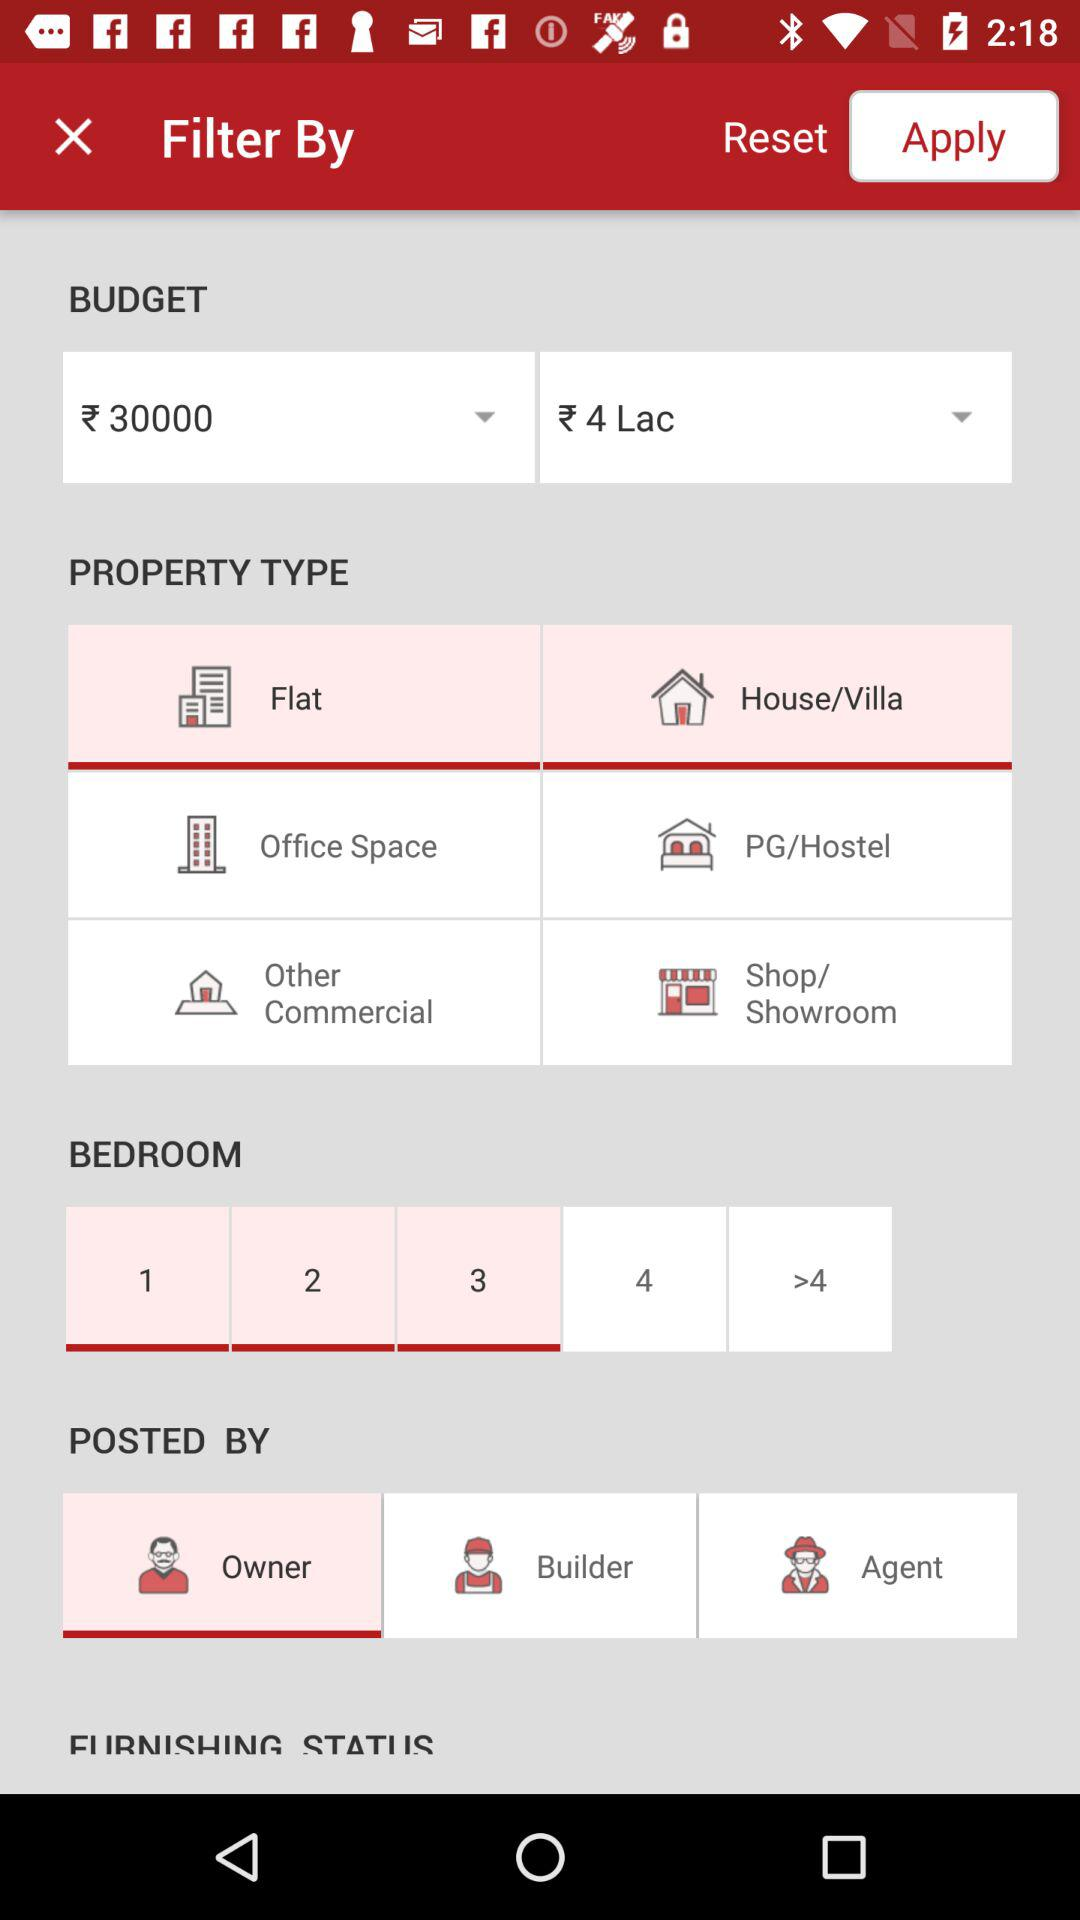What are the different sorts of properties available? The different sorts of properties available are "Flat", "House/Villa", "Office Space", "PG/Hostel", "Other Commercial" and "Shop/Showroom". 